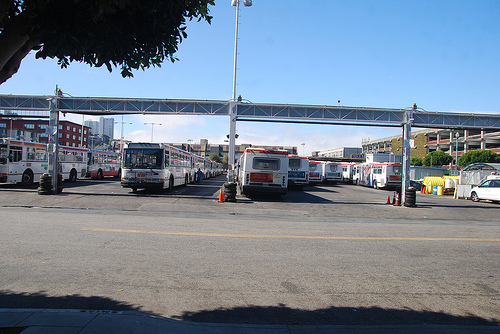Can you describe the time of day and weather conditions in this picture? The shadows are short, suggesting it's around midday. The sky is clear and blue, indicative of fair weather conditions, likely sunny and warm. 